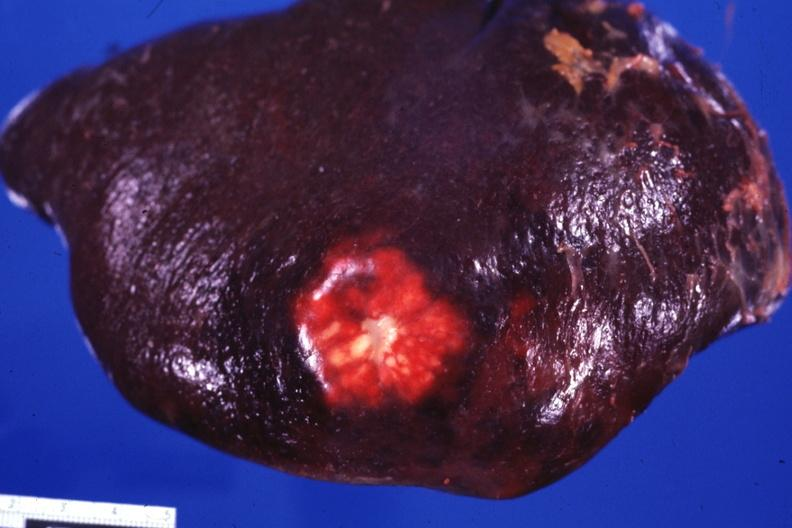s spleen present?
Answer the question using a single word or phrase. Yes 